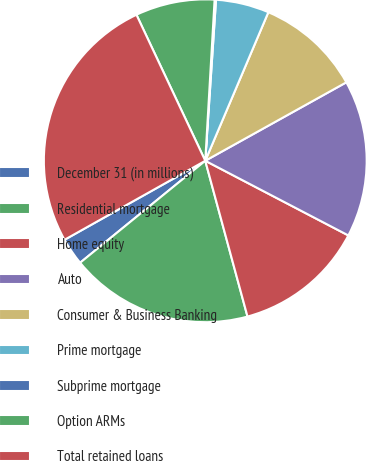Convert chart to OTSL. <chart><loc_0><loc_0><loc_500><loc_500><pie_chart><fcel>December 31 (in millions)<fcel>Residential mortgage<fcel>Home equity<fcel>Auto<fcel>Consumer & Business Banking<fcel>Prime mortgage<fcel>Subprime mortgage<fcel>Option ARMs<fcel>Total retained loans<nl><fcel>2.74%<fcel>18.33%<fcel>13.13%<fcel>15.73%<fcel>10.53%<fcel>5.33%<fcel>0.14%<fcel>7.93%<fcel>26.13%<nl></chart> 